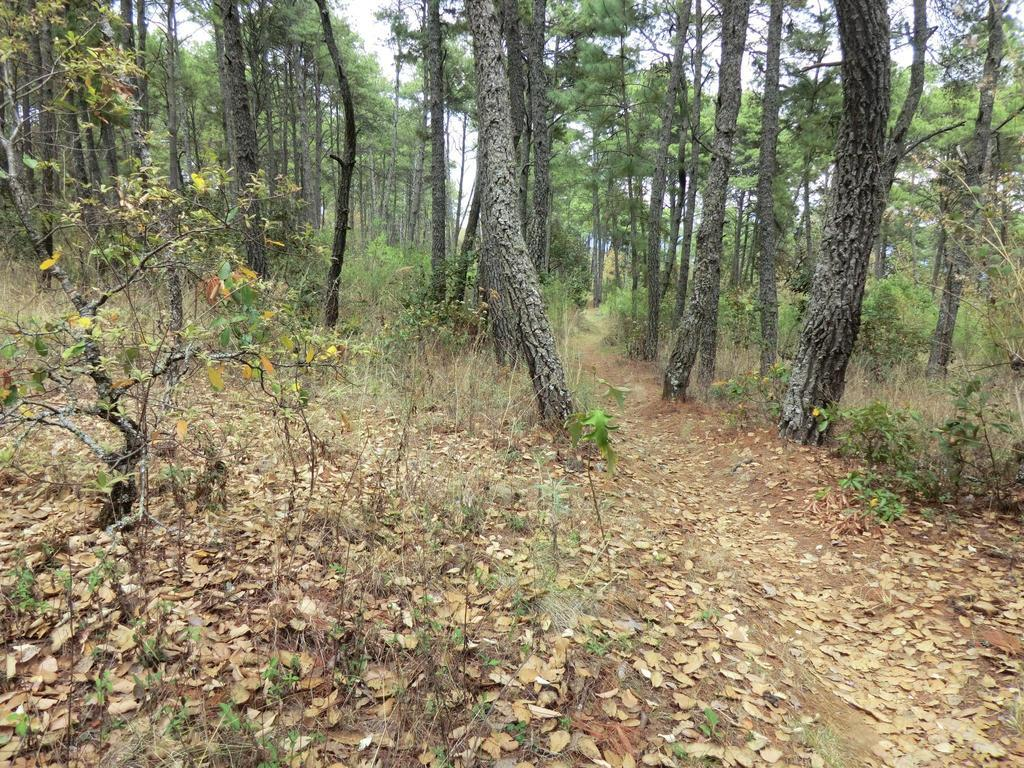What is visible in the foreground of the image? The trunk of trees is visible in the foreground of the image. What can be seen on the surface of the trees in the image? Leaves are present on the surface of the trees. What is visible in the background of the image? Trees are visible in the background of the image. What type of gate can be seen in the image? There is no gate present in the image; it features trees with trunks and leaves. What is the baby doing in the image? There is no baby present in the image. 